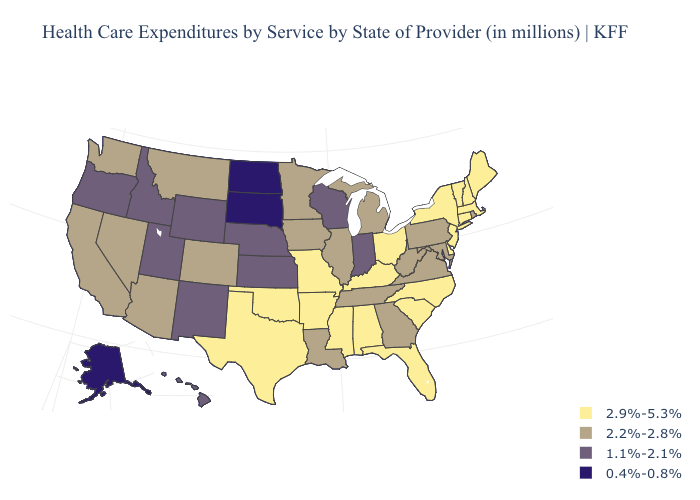What is the value of Wyoming?
Keep it brief. 1.1%-2.1%. What is the value of Louisiana?
Concise answer only. 2.2%-2.8%. Does New Jersey have the lowest value in the Northeast?
Short answer required. No. Does West Virginia have the lowest value in the South?
Be succinct. Yes. Among the states that border California , does Arizona have the highest value?
Quick response, please. Yes. What is the value of Arizona?
Give a very brief answer. 2.2%-2.8%. Name the states that have a value in the range 2.9%-5.3%?
Keep it brief. Alabama, Arkansas, Connecticut, Delaware, Florida, Kentucky, Maine, Massachusetts, Mississippi, Missouri, New Hampshire, New Jersey, New York, North Carolina, Ohio, Oklahoma, South Carolina, Texas, Vermont. What is the lowest value in the West?
Give a very brief answer. 0.4%-0.8%. Among the states that border Texas , does Arkansas have the highest value?
Keep it brief. Yes. Name the states that have a value in the range 2.9%-5.3%?
Short answer required. Alabama, Arkansas, Connecticut, Delaware, Florida, Kentucky, Maine, Massachusetts, Mississippi, Missouri, New Hampshire, New Jersey, New York, North Carolina, Ohio, Oklahoma, South Carolina, Texas, Vermont. What is the value of Nebraska?
Be succinct. 1.1%-2.1%. Name the states that have a value in the range 2.9%-5.3%?
Keep it brief. Alabama, Arkansas, Connecticut, Delaware, Florida, Kentucky, Maine, Massachusetts, Mississippi, Missouri, New Hampshire, New Jersey, New York, North Carolina, Ohio, Oklahoma, South Carolina, Texas, Vermont. Is the legend a continuous bar?
Answer briefly. No. Is the legend a continuous bar?
Write a very short answer. No. Name the states that have a value in the range 2.9%-5.3%?
Short answer required. Alabama, Arkansas, Connecticut, Delaware, Florida, Kentucky, Maine, Massachusetts, Mississippi, Missouri, New Hampshire, New Jersey, New York, North Carolina, Ohio, Oklahoma, South Carolina, Texas, Vermont. 